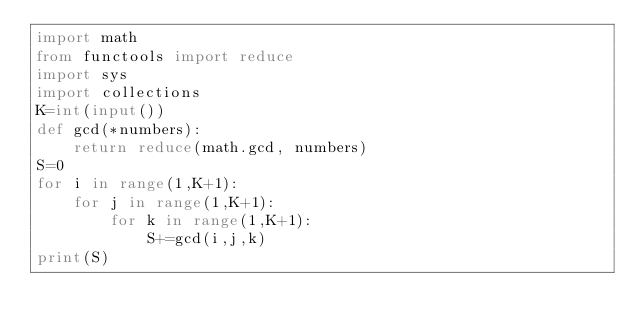<code> <loc_0><loc_0><loc_500><loc_500><_Python_>import math
from functools import reduce
import sys
import collections
K=int(input())
def gcd(*numbers):
    return reduce(math.gcd, numbers)
S=0
for i in range(1,K+1):
    for j in range(1,K+1):
        for k in range(1,K+1):
            S+=gcd(i,j,k)
print(S)

</code> 